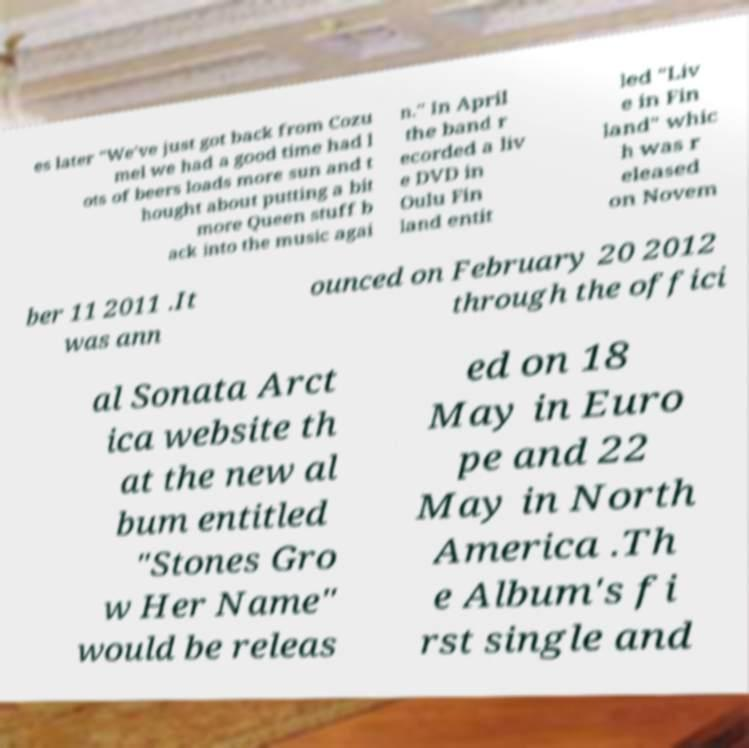I need the written content from this picture converted into text. Can you do that? es later "We've just got back from Cozu mel we had a good time had l ots of beers loads more sun and t hought about putting a bit more Queen stuff b ack into the music agai n." In April the band r ecorded a liv e DVD in Oulu Fin land entit led "Liv e in Fin land" whic h was r eleased on Novem ber 11 2011 .It was ann ounced on February 20 2012 through the offici al Sonata Arct ica website th at the new al bum entitled "Stones Gro w Her Name" would be releas ed on 18 May in Euro pe and 22 May in North America .Th e Album's fi rst single and 